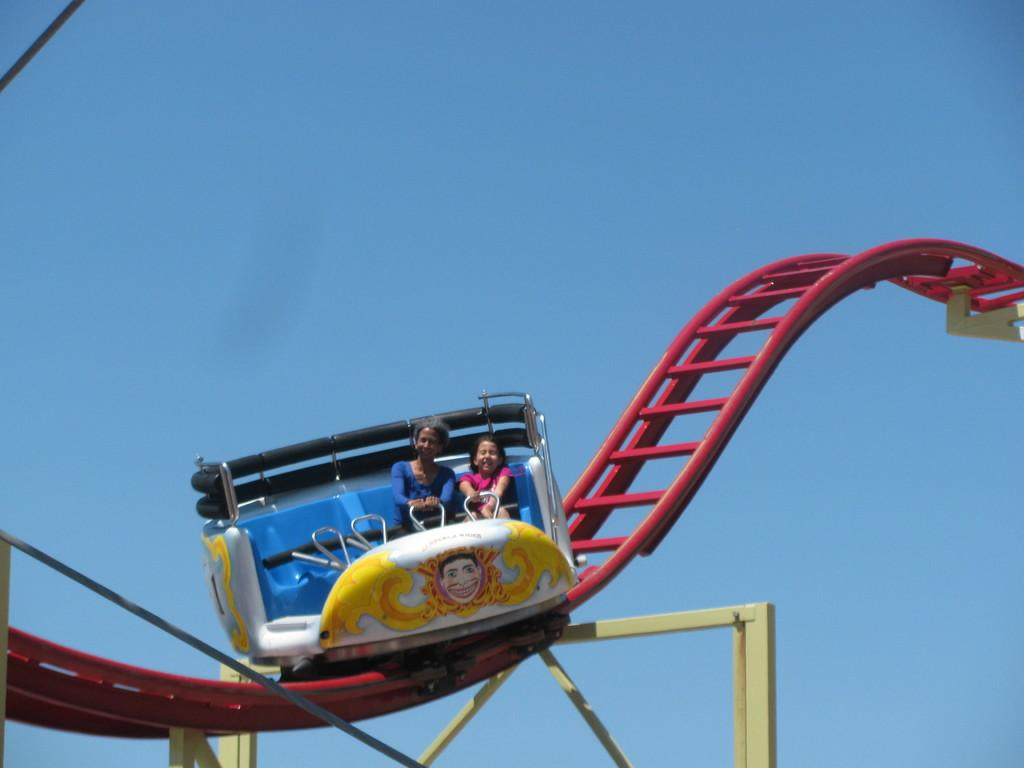What can be seen in the background of the image? There is a sky in the image. What is the main subject in the image? There is a roller coaster in the image. Are there any people in the image? Yes, two people are sitting in the roller coaster. What type of salt is being used to season the roller coaster in the image? There is no salt present in the image, as it features a roller coaster and people sitting in it. 